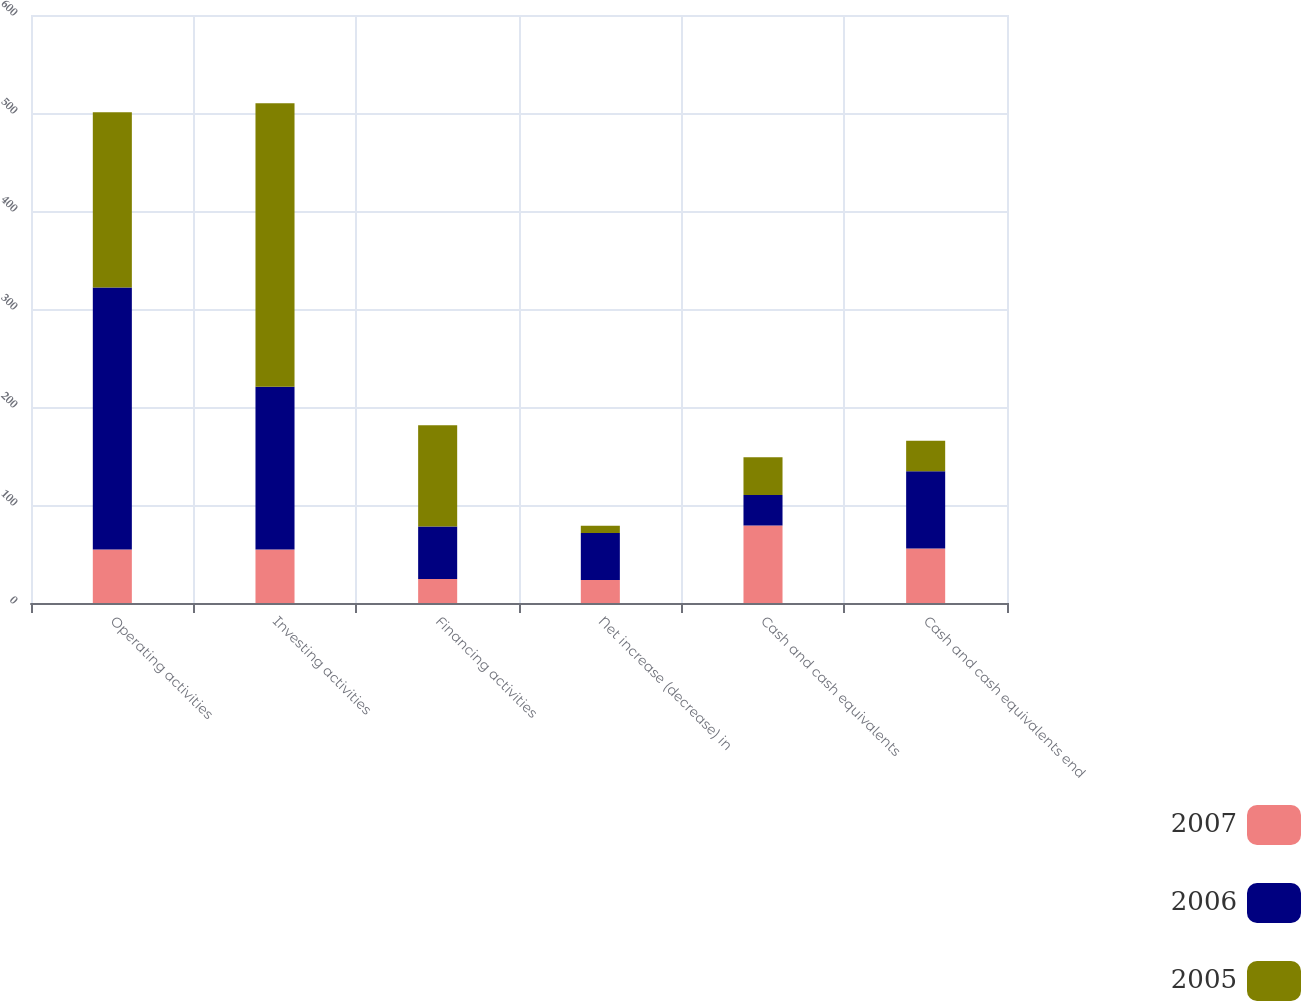Convert chart. <chart><loc_0><loc_0><loc_500><loc_500><stacked_bar_chart><ecel><fcel>Operating activities<fcel>Investing activities<fcel>Financing activities<fcel>Net increase (decrease) in<fcel>Cash and cash equivalents<fcel>Cash and cash equivalents end<nl><fcel>2007<fcel>54.55<fcel>54.55<fcel>24.5<fcel>23.5<fcel>79<fcel>55.5<nl><fcel>2006<fcel>267.5<fcel>166<fcel>53.6<fcel>47.9<fcel>31.1<fcel>79<nl><fcel>2005<fcel>178.8<fcel>289.5<fcel>103.2<fcel>7.5<fcel>38.6<fcel>31.1<nl></chart> 